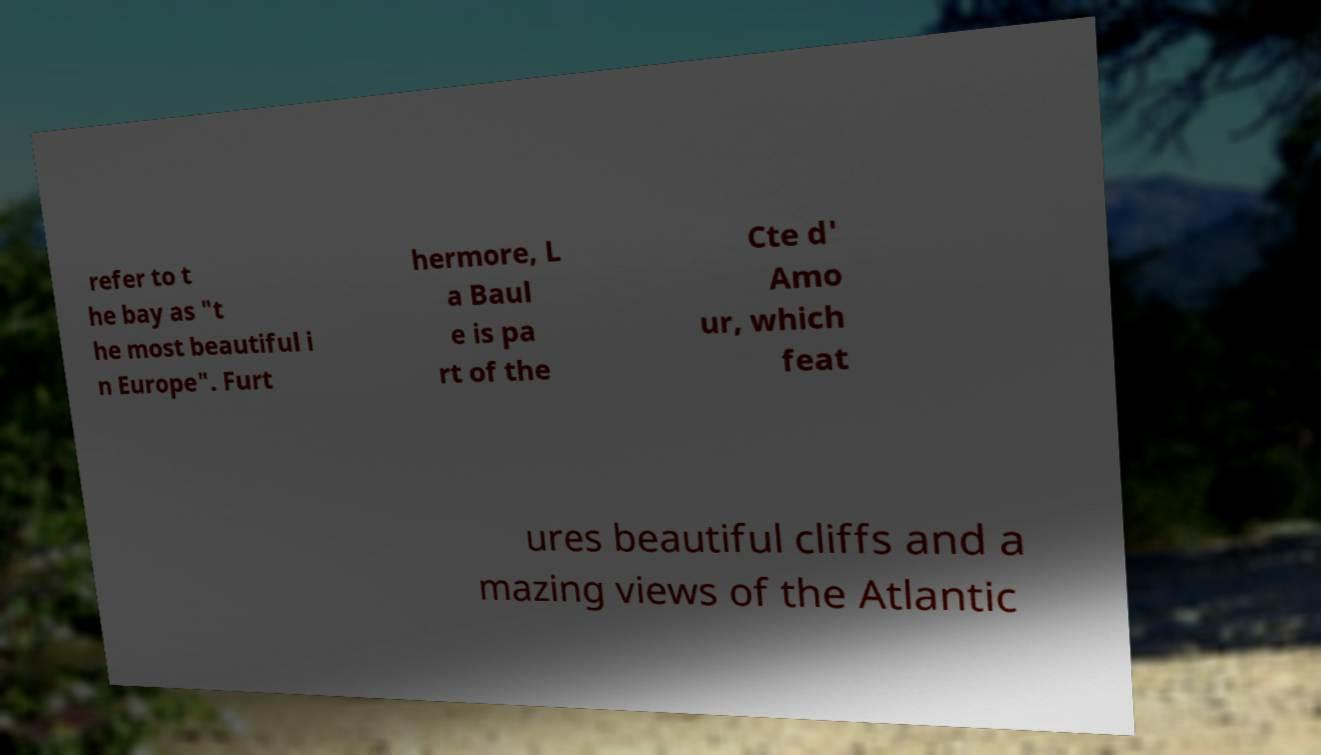What messages or text are displayed in this image? I need them in a readable, typed format. refer to t he bay as "t he most beautiful i n Europe". Furt hermore, L a Baul e is pa rt of the Cte d' Amo ur, which feat ures beautiful cliffs and a mazing views of the Atlantic 